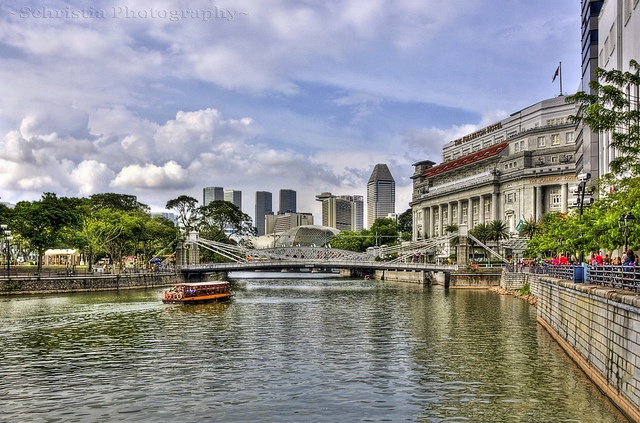Describe the objects in this image and their specific colors. I can see boat in darkgray, black, maroon, brown, and red tones, people in darkgray, black, navy, gray, and maroon tones, people in darkgray, red, maroon, salmon, and black tones, people in darkgray, red, brown, maroon, and salmon tones, and people in darkgray, brown, and maroon tones in this image. 